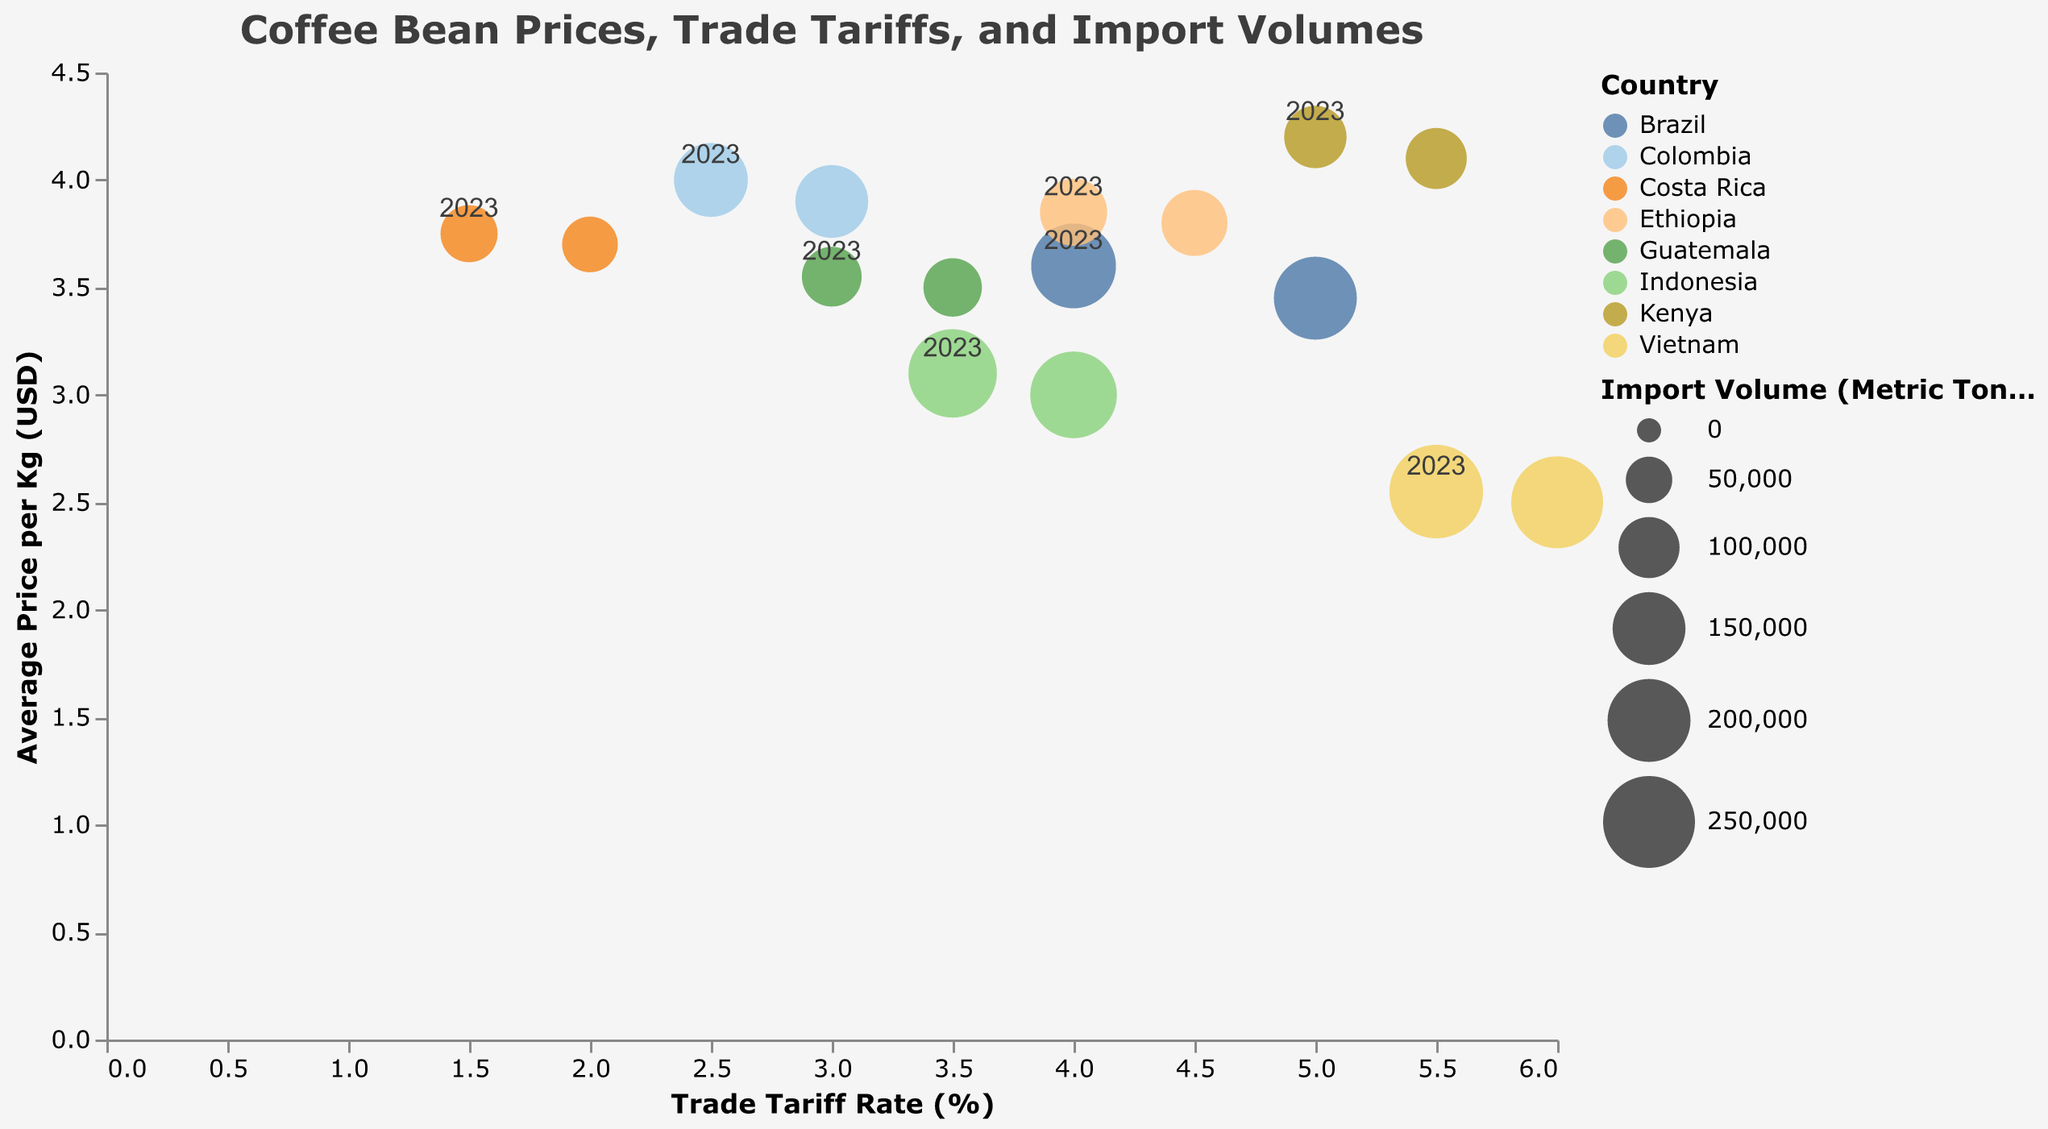What is the relationship between the trade tariff rate and the average price per kg shown in the figure? The horizontal axis represents the trade tariff rate, while the vertical axis represents the average price per kg. Most data points seem to reflect a general trend where lower trade tariffs correspond to higher average prices per kg and vice versa.
Answer: Inversely related Which country had the highest average price per kg of coffee beans in 2023? By interpreting the color-coded legend and the highest point on the y-axis for 2023, we see Kenya in 2023 has the highest average price per kg at $4.20.
Answer: Kenya Which country shows the largest import volume in the data for 2023, and what is that volume? By looking at the size of the circles for 2023, the largest circle size corresponds to Vietnam, with an import volume of 260,000 metric tons.
Answer: Vietnam, 260,000 metric tons What is the difference in the trade tariff rate for Colombia between the years 2022 and 2023? From the tooltip info, Colombia's trade tariff rate in 2022 was 3.0%, and in 2023 it was 2.5%. The difference is calculated as 3.0% - 2.5% = 0.5%.
Answer: 0.5% How does the average price per kg of coffee beans in Ethiopia compare between 2022 and 2023? From the tooltips, Ethiopia's average price per kg is $3.80 in 2022 and $3.85 in 2023. The price has increased by $0.05.
Answer: Increased by $0.05 Which country has the largest change in import volume from 2022 to 2023? By comparing the sizes of each country's circles across 2022 and 2023 and checking the tooltip values, Vietnam shows the largest difference from 250,000 to 260,000 metric tons—a 10,000 metric ton increase.
Answer: Vietnam What is the average trade tariff rate across all the countries in the figure for 2023? To find the average trade tariff rate for 2023, sum all the individual tariff rates for 2023 and divide by the number of countries: (4.0 + 2.5 + 5.5 + 4.0 + 5.0 + 3.5 + 1.5 + 3.0) / 8 = 3.625%.
Answer: 3.625% How are the import volumes represented in the figure? Import volumes are represented by the size of the circles; larger circles indicate higher import volumes, as stated in the figure's legend.
Answer: Circle size Which country had a decreasing trend in both trade tariff rates and average coffee prices from 2022 to 2023? Observing the tooltip for each data point, none of the countries can be seen where both trade tariffs and average prices have decreased in 2023 compared to 2022.
Answer: None 